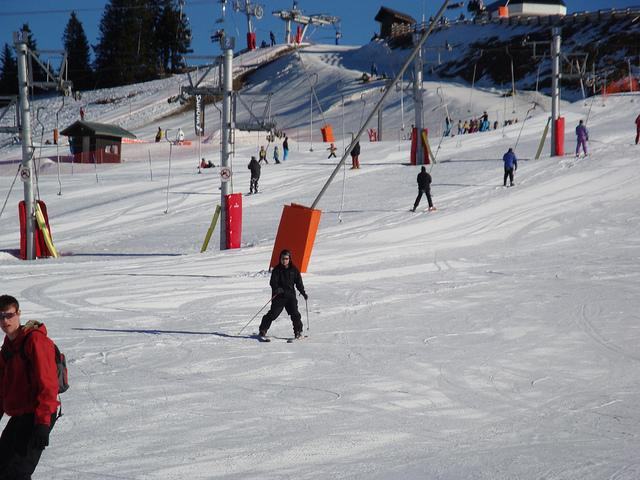What is the man dressed in all black and in the middle of the scene holding?

Choices:
A) carrot
B) rabbit
C) ski poles
D) baby ski poles 